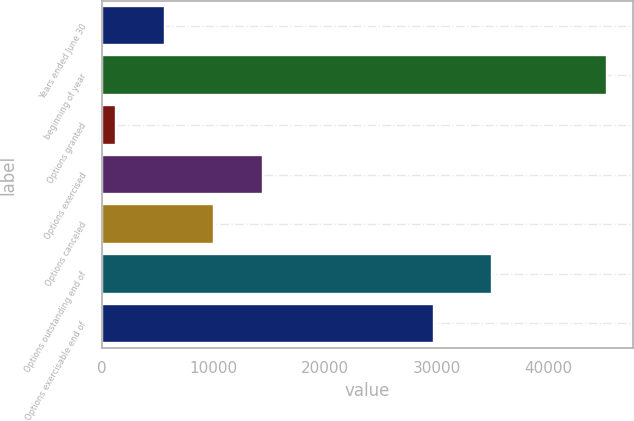Convert chart. <chart><loc_0><loc_0><loc_500><loc_500><bar_chart><fcel>Years ended June 30<fcel>beginning of year<fcel>Options granted<fcel>Options exercised<fcel>Options canceled<fcel>Options outstanding end of<fcel>Options exercisable end of<nl><fcel>5670.5<fcel>45320<fcel>1265<fcel>14481.5<fcel>10076<fcel>35000<fcel>29781<nl></chart> 